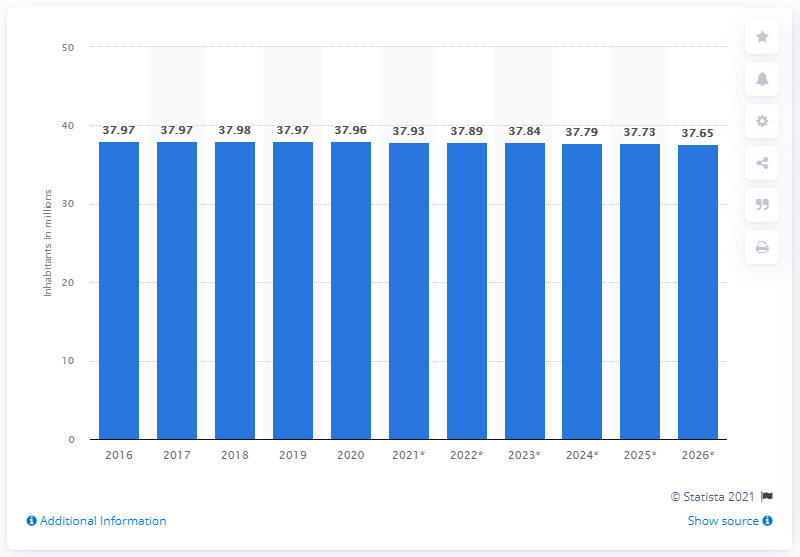What might be the consequences of this population decline for Poland? The decline in Poland's population as indicated by the graph could have several consequences, such as potential labor shortages, increased pressure on social security systems, and challenges in maintaining economic growth. It might also affect internal demographic structures, like the age distribution, potentially leading to an aging population. 